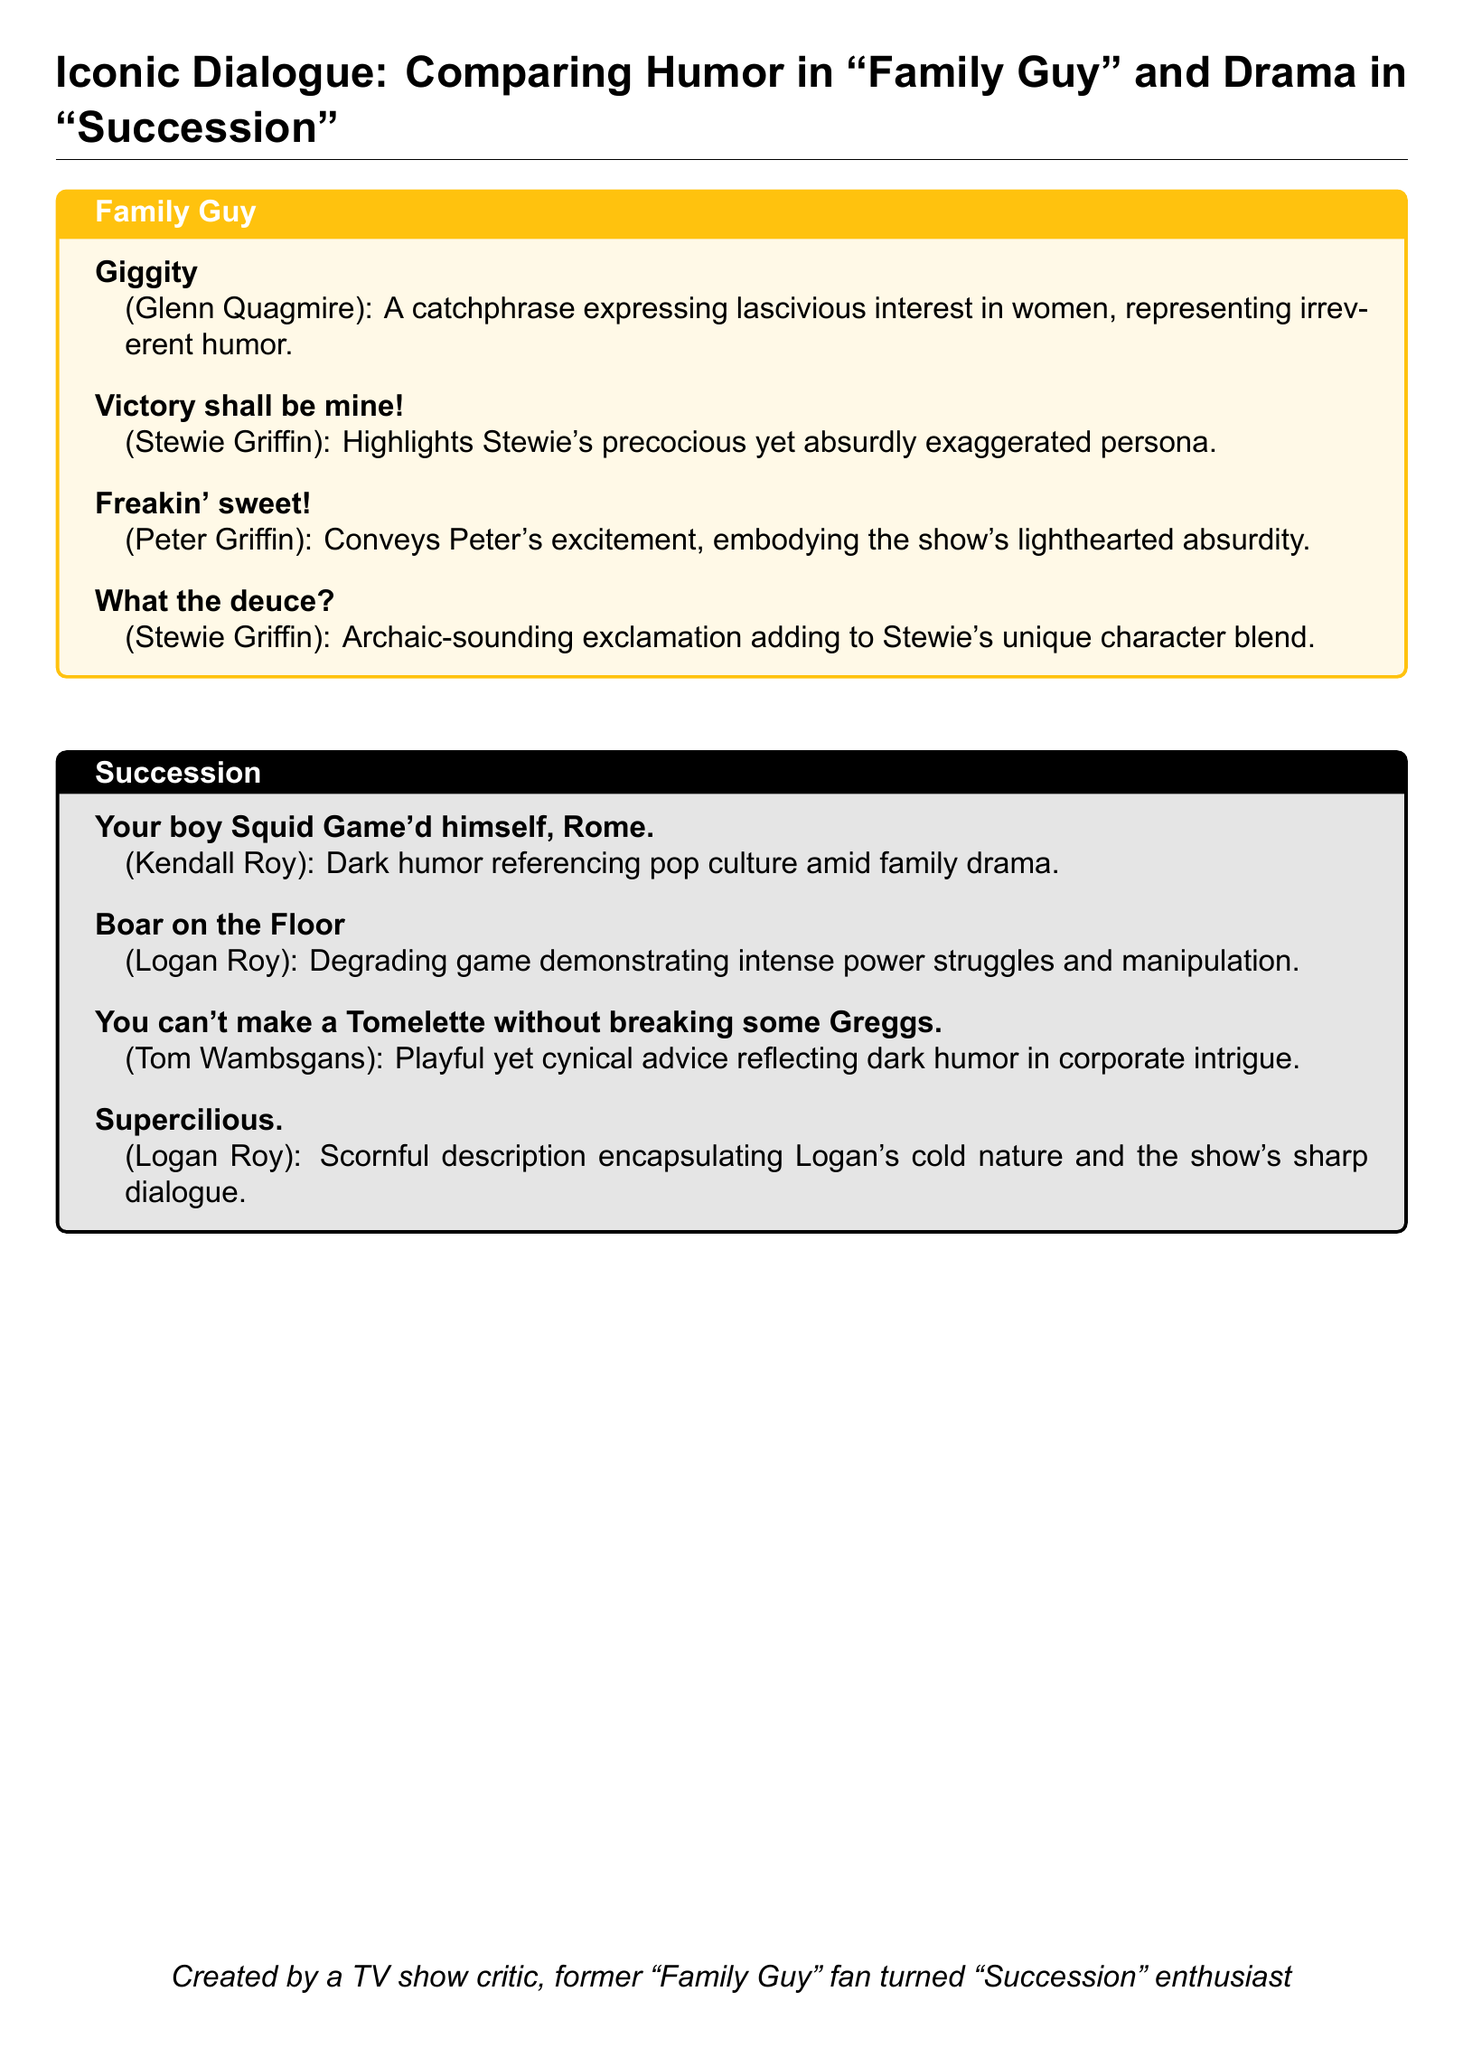What is the catchphrase of Glenn Quagmire? The document lists "Giggity" as the catchphrase of Glenn Quagmire in the Family Guy section.
Answer: Giggity Who said "Supercilious."? This phrase is attributed to Logan Roy in the Succession section of the document.
Answer: Logan Roy What game illustrates intense power struggles in Succession? The term "Boar on the Floor" is mentioned as a game that demonstrates power struggles in the document.
Answer: Boar on the Floor Which character highlights a precocious yet absurd persona? The document mentions Stewie Griffin as showcasing a precocious yet absurd persona through his dialogue.
Answer: Stewie Griffin What type of humor does Kendall Roy's dialogue reference? The document indicates that Kendall Roy's dialogue includes dark humor referencing pop culture amid family drama.
Answer: Dark humor What color theme represents Family Guy in the document? The document specifies the color familyguy as RGB(255,194,14) representing Family Guy.
Answer: RGB(255,194,14) Which character uses the phrase about breaking Greggs? The line "You can't make a Tomelette without breaking some Greggs" is attributed to Tom Wambsgans according to the document.
Answer: Tom Wambsgans What does the phrase "Freakin' sweet!" express? The document describes "Freakin' sweet!" as conveying excitement and embodying the show's lighthearted absurdity.
Answer: Excitement What common theme is present in both Family Guy and Succession dialogues? Both dialogue sets demonstrate unique humor or drama traits, with Family Guy leaning towards irreverent humor and Succession toward sharp drama.
Answer: Unique humor or drama traits 